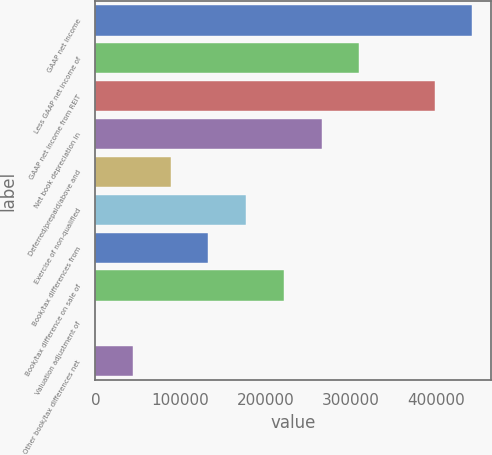Convert chart. <chart><loc_0><loc_0><loc_500><loc_500><bar_chart><fcel>GAAP net income<fcel>Less GAAP net income of<fcel>GAAP net income from REIT<fcel>Net book depreciation in<fcel>Deferred/prepaid/above and<fcel>Exercise of non-qualified<fcel>Book/tax differences from<fcel>Book/tax difference on sale of<fcel>Valuation adjustment of<fcel>Other book/tax differences net<nl><fcel>442830<fcel>309996<fcel>398552<fcel>265718<fcel>88606.8<fcel>177163<fcel>132885<fcel>221440<fcel>51<fcel>44328.9<nl></chart> 